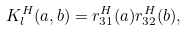<formula> <loc_0><loc_0><loc_500><loc_500>K _ { l } ^ { H } ( a , b ) = r _ { 3 1 } ^ { H } ( a ) r _ { 3 2 } ^ { H } ( b ) ,</formula> 